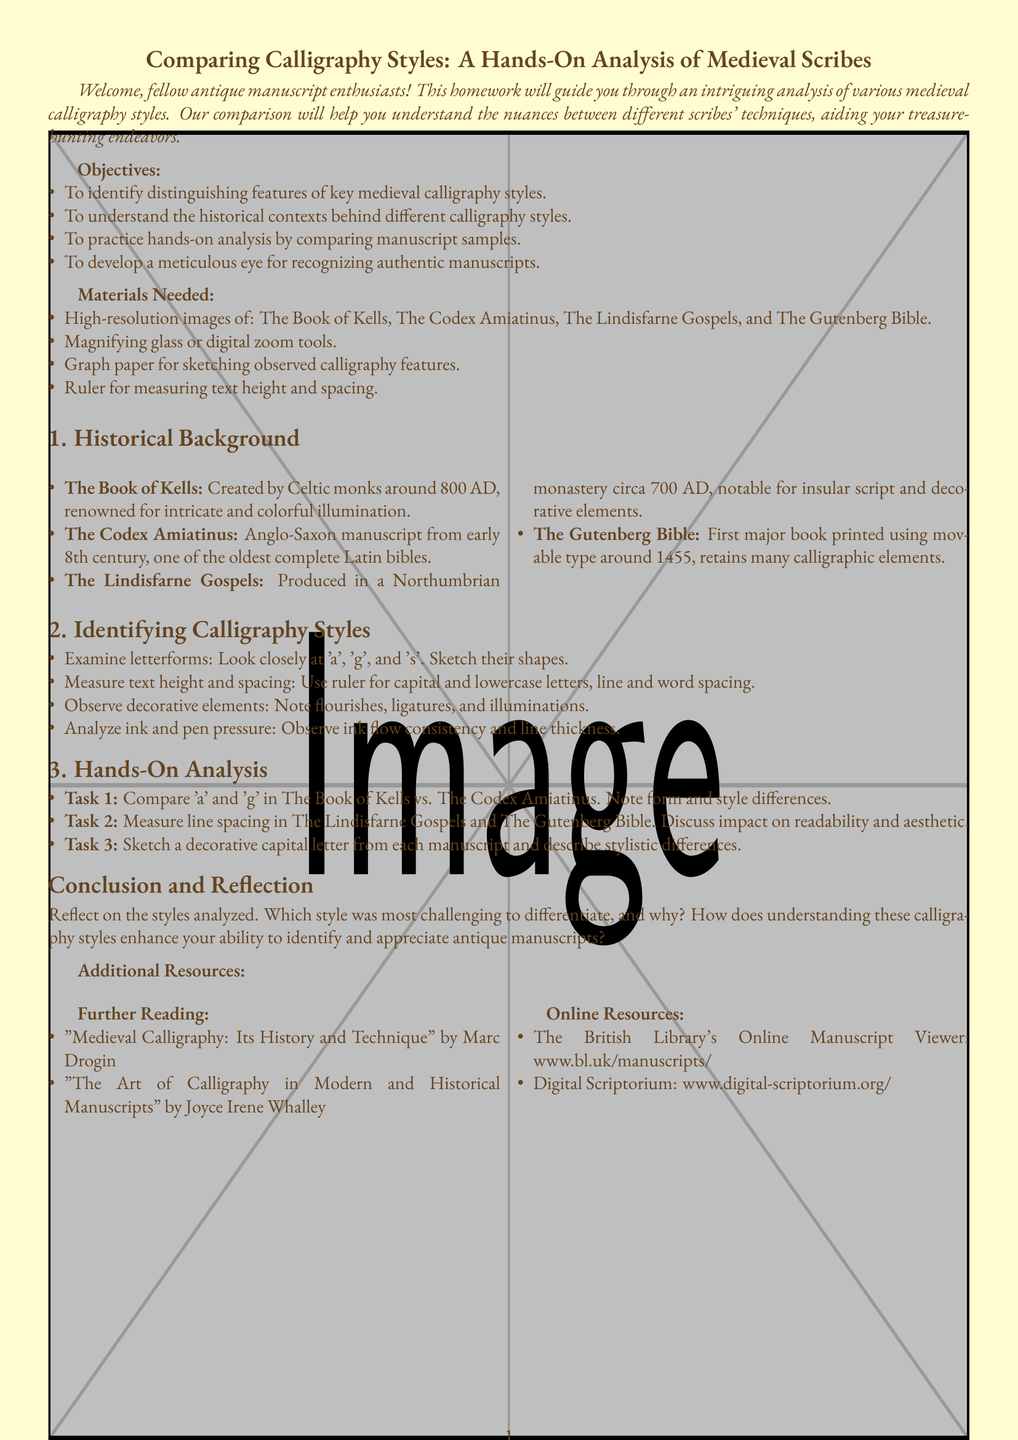What year was The Book of Kells created? The Book of Kells was created around 800 AD, as stated in the historical background section of the document.
Answer: 800 AD Who created The Codex Amiatinus? The document states that The Codex Amiatinus was created by Anglo-Saxon monks in the early 8th century.
Answer: Anglo-Saxon monks What two letters should be compared in Task 1? Task 1 specifies to compare the letters 'a' and 'g' in the designated manuscripts.
Answer: 'a' and 'g' Which manuscript is noted for decorative elements in the script? The Lindisfarne Gospels is particularly mentioned for its insular script and decorative elements in the historical background.
Answer: The Lindisfarne Gospels How many materials are listed in the Materials Needed section? The document enumerates four materials needed for the analysis, providing a succinct list.
Answer: Four What key activity is suggested for measuring text? The document advises to measure text height and spacing using a ruler.
Answer: Measure with a ruler Which book is noted as the first printed using movable type? According to the historical background, The Gutenberg Bible is recognized as the first major book printed using movable type.
Answer: The Gutenberg Bible In which section is the hands-on analysis described? The hands-on analysis is described in Section 3 of the document.
Answer: Section 3 What is the main objective of the homework assignment? One of the main objectives is to identify distinguishing features of key medieval calligraphy styles.
Answer: Identify distinguishing features 